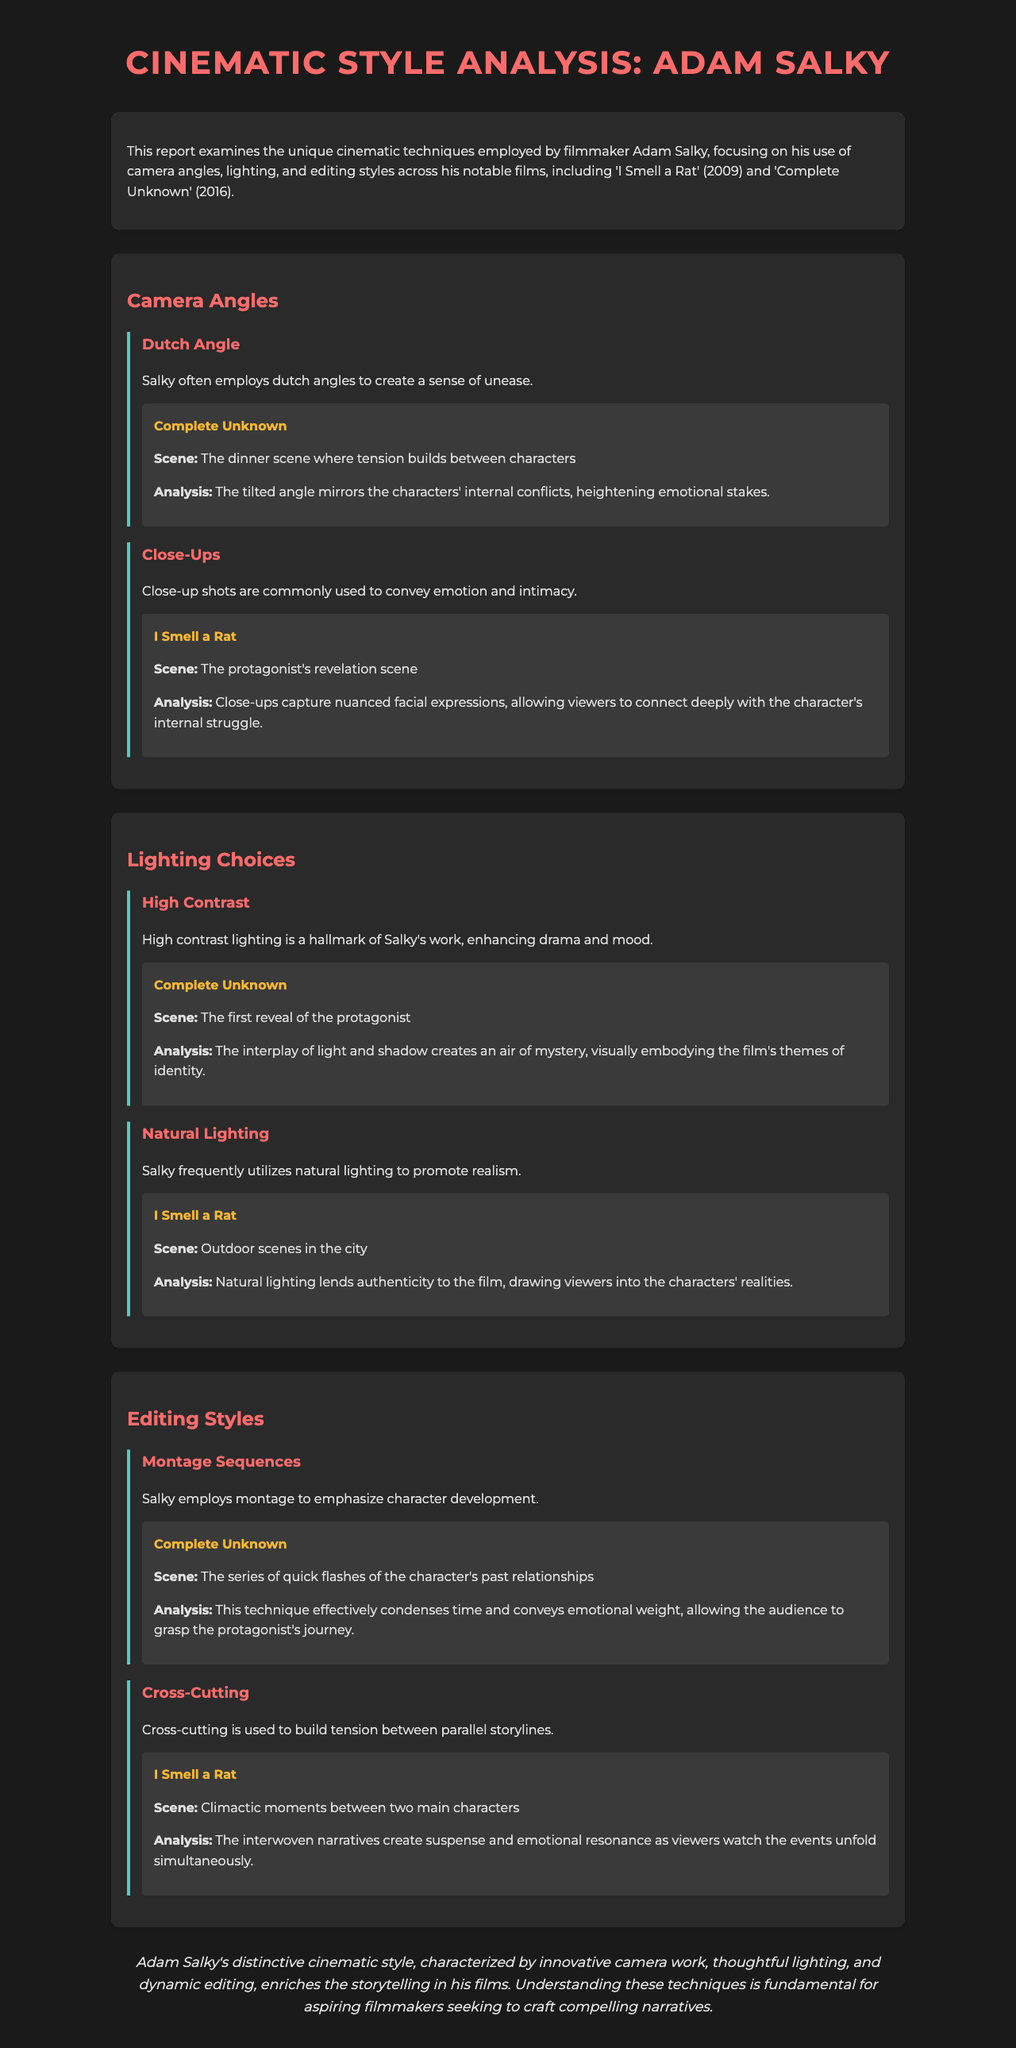What are the two notable films analyzed in the report? The report specifically mentions 'I Smell a Rat' and 'Complete Unknown' as the notable films explored.
Answer: 'I Smell a Rat' and 'Complete Unknown' What technique does Salky use to create a sense of unease? The report states that Salky employs dutch angles to create a sense of unease in his films.
Answer: Dutch angles Which lighting choice enhances drama and mood in Salky's films? The report identifies high contrast lighting as a hallmark of Salky's work, used to enhance drama and mood.
Answer: High contrast What editing technique emphasizes character development in Salky's films? According to the document, montage sequences are used by Salky to emphasize character development.
Answer: Montage sequences In which film does the protagonist's revelation scene occur? The document specifies that the protagonist's revelation scene takes place in 'I Smell a Rat'.
Answer: 'I Smell a Rat' What visual technique is used to draw viewers into the characters' realities? The report describes the use of natural lighting as a technique to promote realism in the films.
Answer: Natural lighting How does Salky's editing style create suspense in the storytelling? Cross-cutting is stated in the report as a technique used by Salky to build tension between parallel storylines.
Answer: Cross-cutting What is the conclusion regarding Adam Salky's cinematic style? The conclusion emphasizes that Salky's cinematic style enriches storytelling through innovative techniques.
Answer: Innovative techniques What was the purpose of the report? The report aims to examine the unique cinematic techniques employed by Adam Salky.
Answer: Examine unique cinematic techniques 